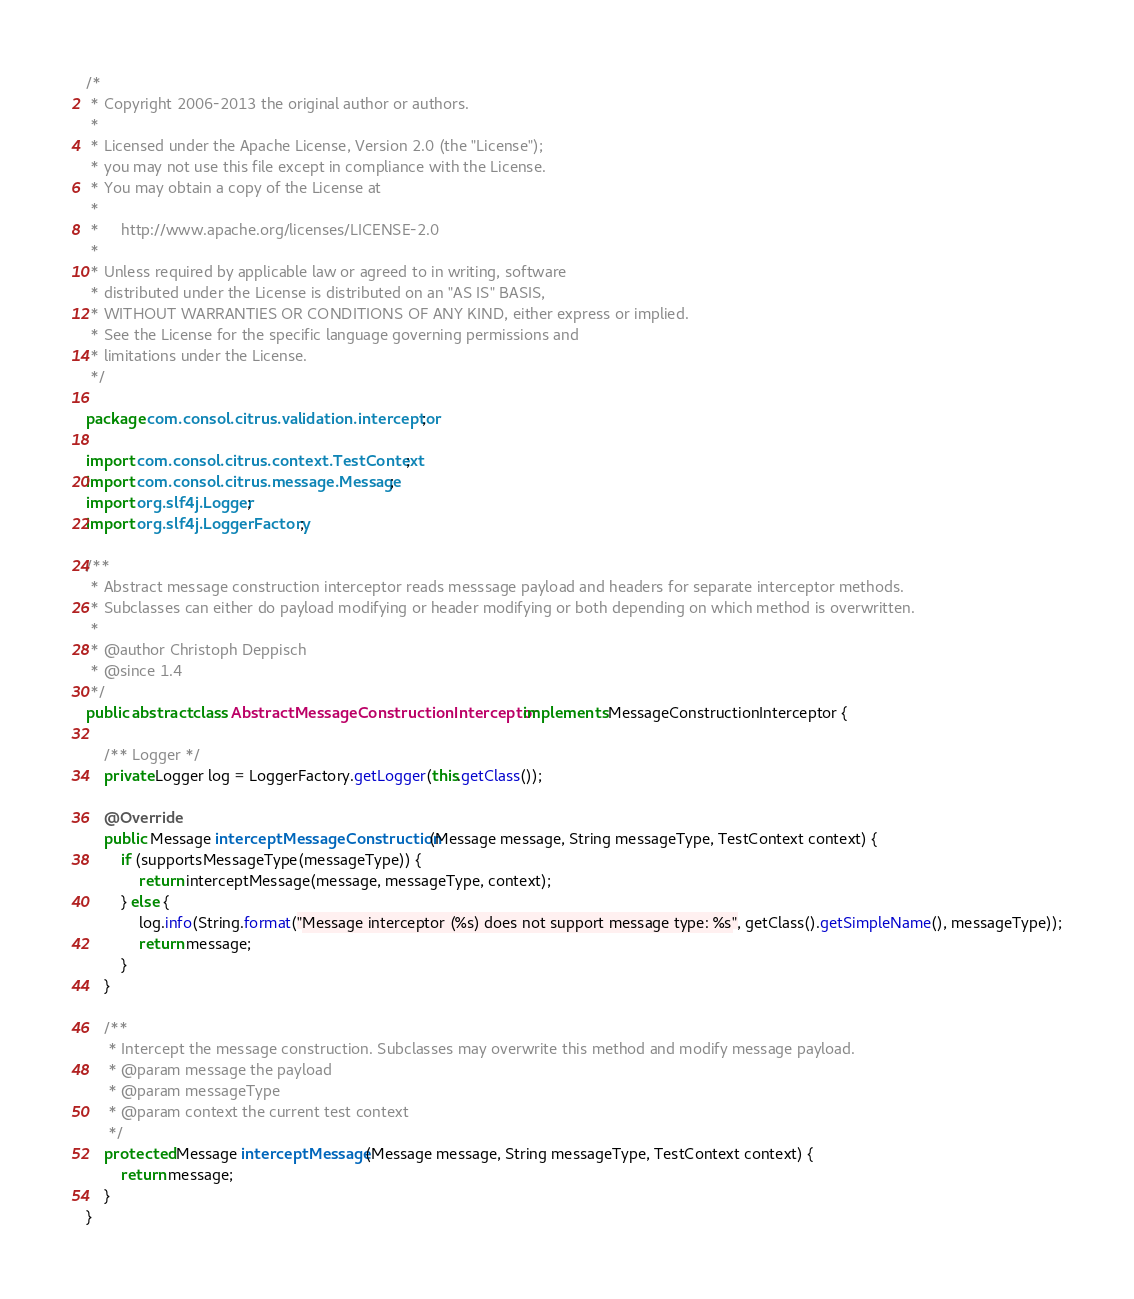Convert code to text. <code><loc_0><loc_0><loc_500><loc_500><_Java_>/*
 * Copyright 2006-2013 the original author or authors.
 *
 * Licensed under the Apache License, Version 2.0 (the "License");
 * you may not use this file except in compliance with the License.
 * You may obtain a copy of the License at
 *
 *     http://www.apache.org/licenses/LICENSE-2.0
 *
 * Unless required by applicable law or agreed to in writing, software
 * distributed under the License is distributed on an "AS IS" BASIS,
 * WITHOUT WARRANTIES OR CONDITIONS OF ANY KIND, either express or implied.
 * See the License for the specific language governing permissions and
 * limitations under the License.
 */

package com.consol.citrus.validation.interceptor;

import com.consol.citrus.context.TestContext;
import com.consol.citrus.message.Message;
import org.slf4j.Logger;
import org.slf4j.LoggerFactory;

/**
 * Abstract message construction interceptor reads messsage payload and headers for separate interceptor methods.
 * Subclasses can either do payload modifying or header modifying or both depending on which method is overwritten.
 *
 * @author Christoph Deppisch
 * @since 1.4
 */
public abstract class AbstractMessageConstructionInterceptor implements MessageConstructionInterceptor {

    /** Logger */
    private Logger log = LoggerFactory.getLogger(this.getClass());

    @Override
    public Message interceptMessageConstruction(Message message, String messageType, TestContext context) {
        if (supportsMessageType(messageType)) {
            return interceptMessage(message, messageType, context);
        } else {
            log.info(String.format("Message interceptor (%s) does not support message type: %s", getClass().getSimpleName(), messageType));
            return message;
        }
    }

    /**
     * Intercept the message construction. Subclasses may overwrite this method and modify message payload.
     * @param message the payload
     * @param messageType
     * @param context the current test context
     */
    protected Message interceptMessage(Message message, String messageType, TestContext context) {
        return message;
    }
}
</code> 